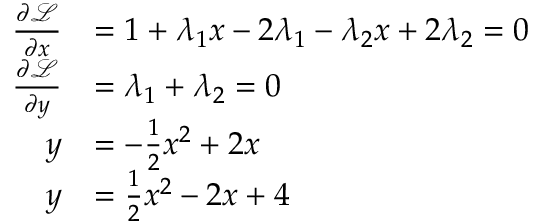Convert formula to latex. <formula><loc_0><loc_0><loc_500><loc_500>\begin{array} { r l } { \frac { \partial \mathcal { L } } { \partial x } } & { = 1 + \lambda _ { 1 } x - 2 \lambda _ { 1 } - \lambda _ { 2 } x + 2 \lambda _ { 2 } = 0 } \\ { \frac { \partial \mathcal { L } } { \partial y } } & { = \lambda _ { 1 } + \lambda _ { 2 } = 0 } \\ { y } & { = - \frac { 1 } { 2 } x ^ { 2 } + 2 x } \\ { y } & { = \frac { 1 } { 2 } x ^ { 2 } - 2 x + 4 } \end{array}</formula> 